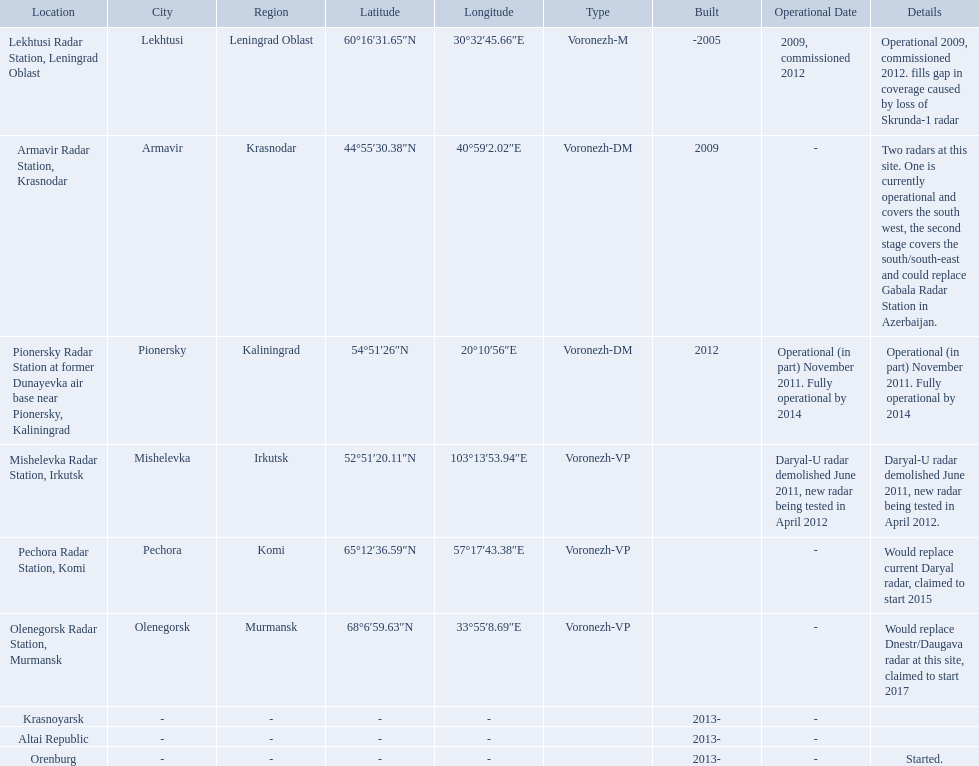What are the list of radar locations? Lekhtusi Radar Station, Leningrad Oblast, Armavir Radar Station, Krasnodar, Pionersky Radar Station at former Dunayevka air base near Pionersky, Kaliningrad, Mishelevka Radar Station, Irkutsk, Pechora Radar Station, Komi, Olenegorsk Radar Station, Murmansk, Krasnoyarsk, Altai Republic, Orenburg. Which of these are claimed to start in 2015? Pechora Radar Station, Komi. Voronezh radar has locations where? Lekhtusi Radar Station, Leningrad Oblast, Armavir Radar Station, Krasnodar, Pionersky Radar Station at former Dunayevka air base near Pionersky, Kaliningrad, Mishelevka Radar Station, Irkutsk, Pechora Radar Station, Komi, Olenegorsk Radar Station, Murmansk, Krasnoyarsk, Altai Republic, Orenburg. Which of these locations have know coordinates? Lekhtusi Radar Station, Leningrad Oblast, Armavir Radar Station, Krasnodar, Pionersky Radar Station at former Dunayevka air base near Pionersky, Kaliningrad, Mishelevka Radar Station, Irkutsk, Pechora Radar Station, Komi, Olenegorsk Radar Station, Murmansk. Which of these locations has coordinates of 60deg16'31.65''n 30deg32'45.66''e / 60.2754583degn 30.5460167dege? Lekhtusi Radar Station, Leningrad Oblast. 